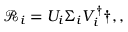Convert formula to latex. <formula><loc_0><loc_0><loc_500><loc_500>\mathcal { R } _ { i } = U _ { i } \Sigma _ { i } V _ { i } ^ { \dagger } \dag , ,</formula> 